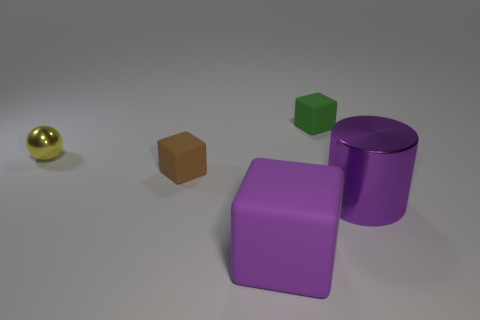What is the material of the object that is the same color as the cylinder? The cube that shares the same purple color as the cylinder appears to be made of a similar matte material, which could be either a type of painted wood or a matte-finish plastic, commonly used in such geometric models for educational or display purposes. 